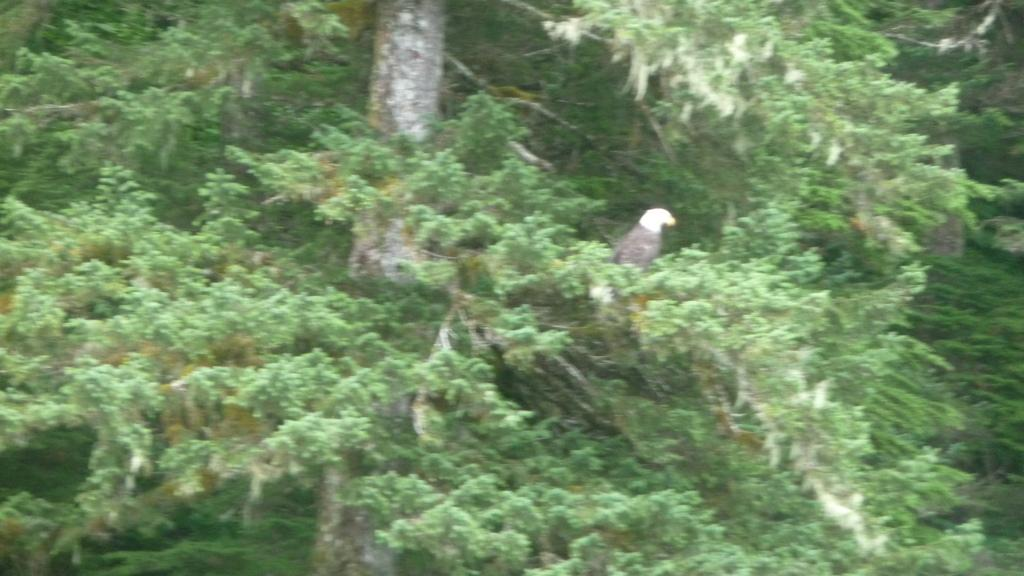What type of animal can be seen in the image? There is a bird in the image. Where is the bird located? The bird is on a tree. What type of ornament is hanging from the bird's beak in the image? There is no ornament hanging from the bird's beak in the image; the bird is simply perched on the tree. 